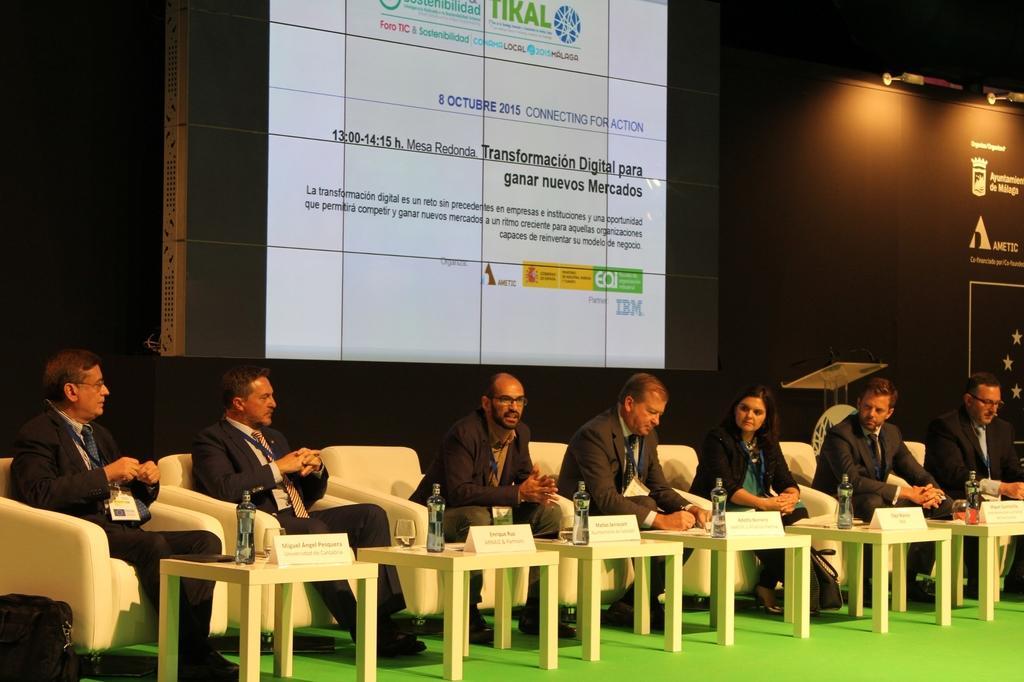How would you summarize this image in a sentence or two? In the middle of the image few people are sitting on a chair. In front of them there are some tables, On the table there is a glass and bottle. Behind them there is a banner. 